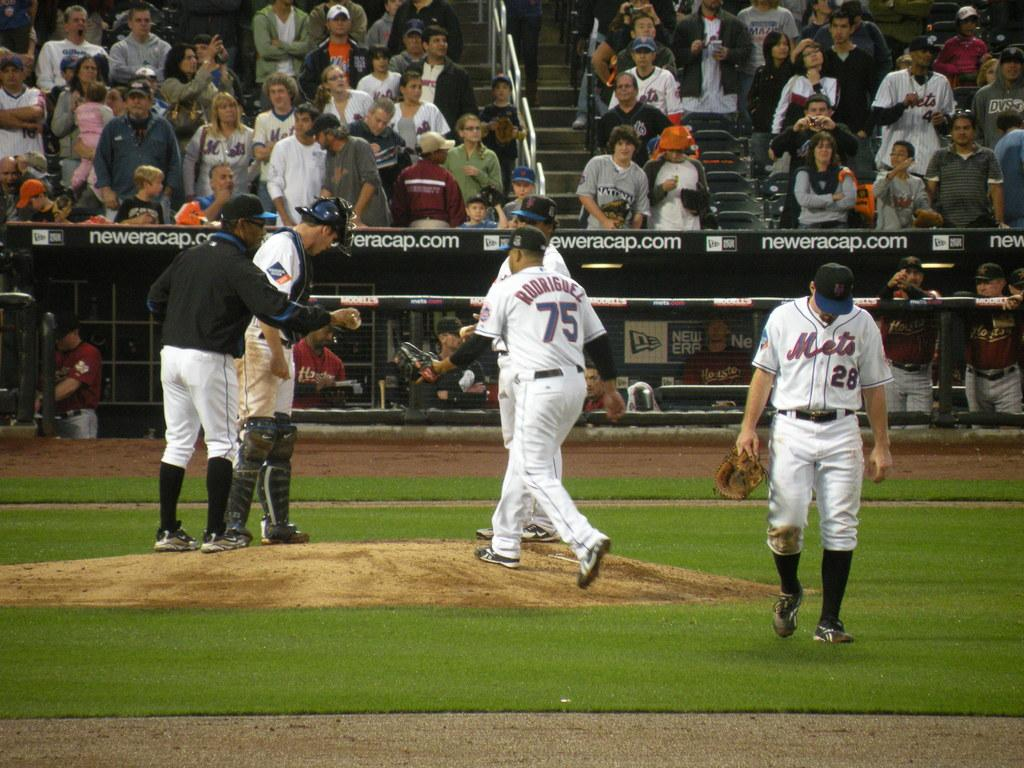<image>
Create a compact narrative representing the image presented. Players for the Mets are talking on the pitchers mound. 